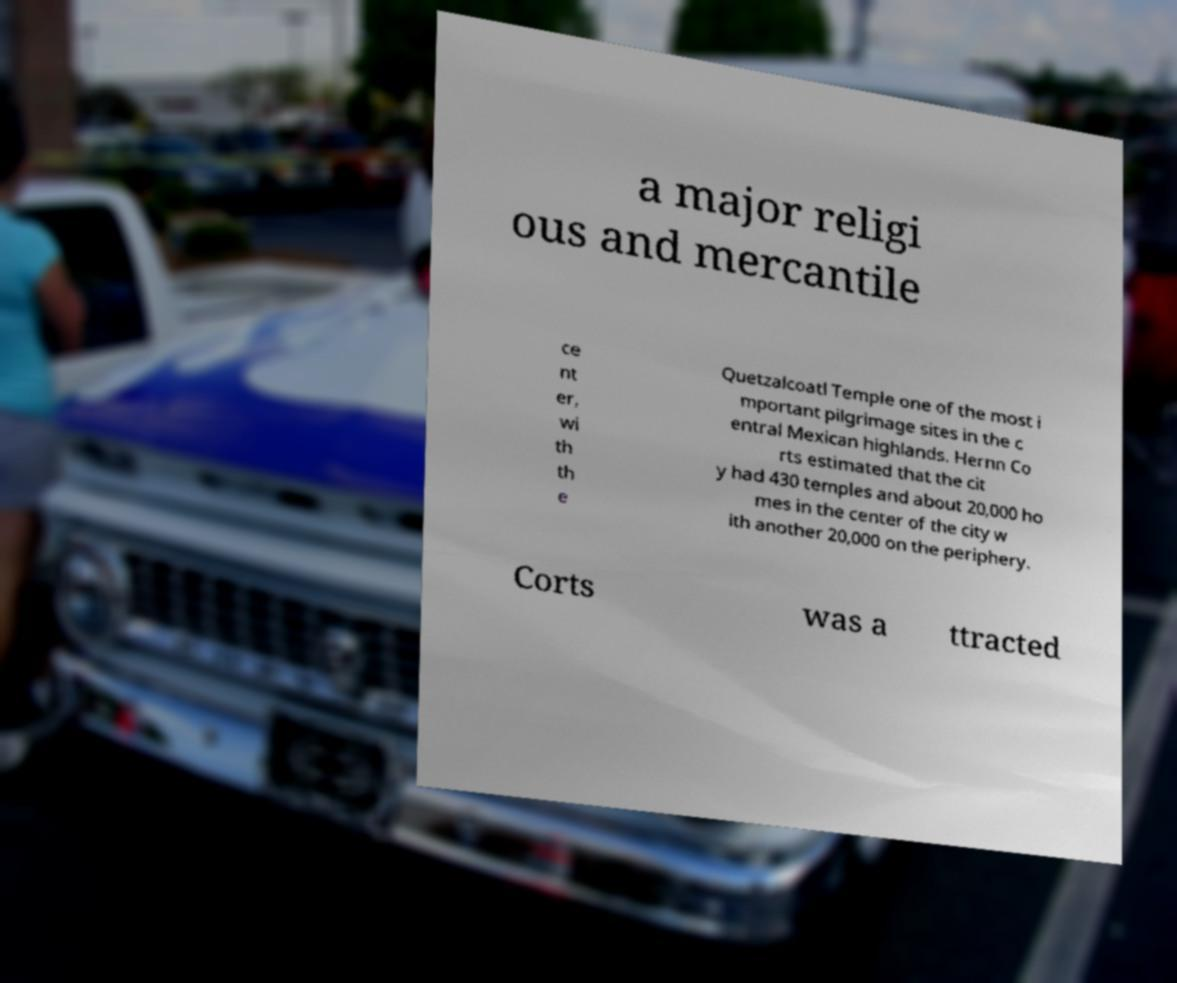There's text embedded in this image that I need extracted. Can you transcribe it verbatim? a major religi ous and mercantile ce nt er, wi th th e Quetzalcoatl Temple one of the most i mportant pilgrimage sites in the c entral Mexican highlands. Hernn Co rts estimated that the cit y had 430 temples and about 20,000 ho mes in the center of the city w ith another 20,000 on the periphery. Corts was a ttracted 